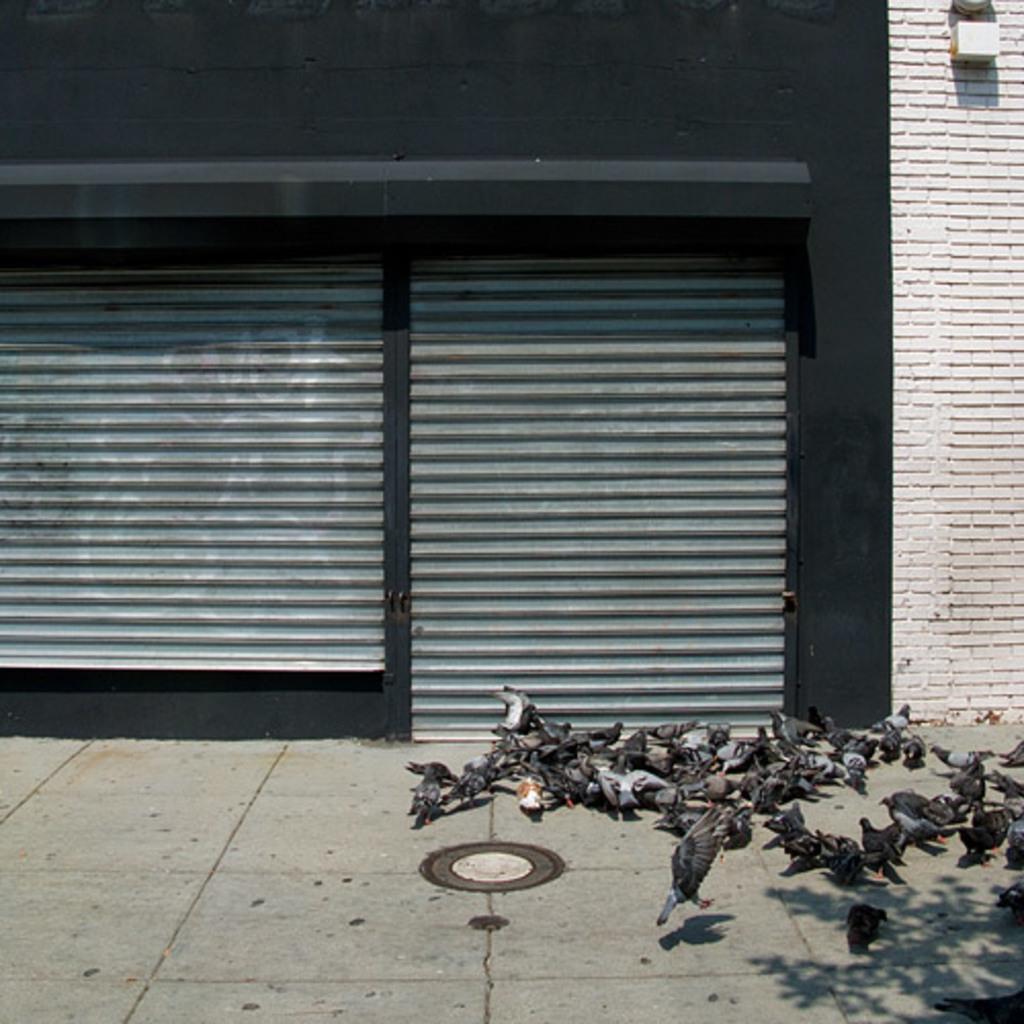Please provide a concise description of this image. This picture is clicked outside. On the right we can see the group of pigeons standing on the ground and seems to be eating some food item and we can see a pigeon seems to be flying in the air. In the background we can see the wall of the building and we can see the shutters and some other items. 